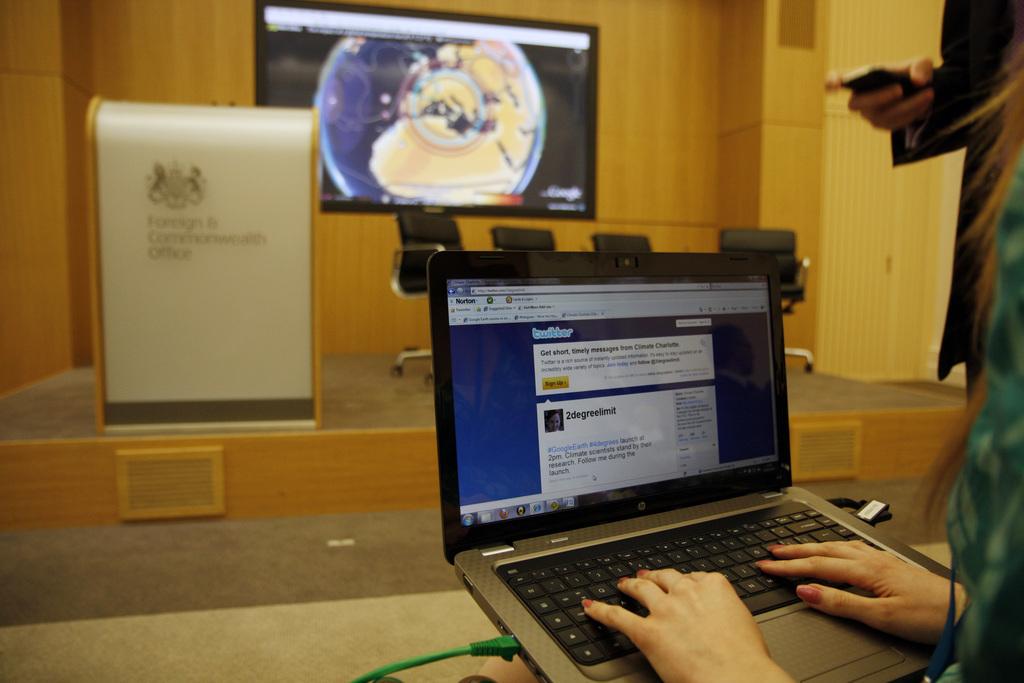What web page is the person using?
Your answer should be compact. Twitter. Who posted the tweet?
Keep it short and to the point. 2degreelimit. 